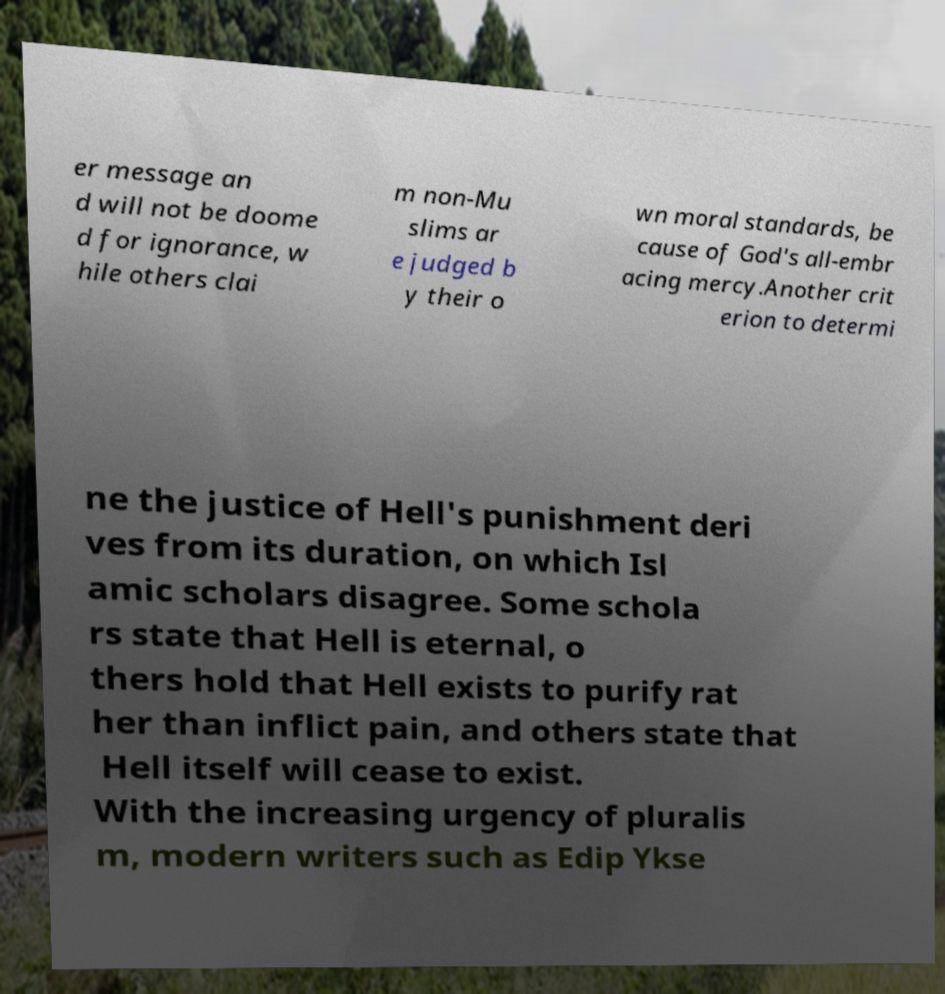There's text embedded in this image that I need extracted. Can you transcribe it verbatim? er message an d will not be doome d for ignorance, w hile others clai m non-Mu slims ar e judged b y their o wn moral standards, be cause of God's all-embr acing mercy.Another crit erion to determi ne the justice of Hell's punishment deri ves from its duration, on which Isl amic scholars disagree. Some schola rs state that Hell is eternal, o thers hold that Hell exists to purify rat her than inflict pain, and others state that Hell itself will cease to exist. With the increasing urgency of pluralis m, modern writers such as Edip Ykse 